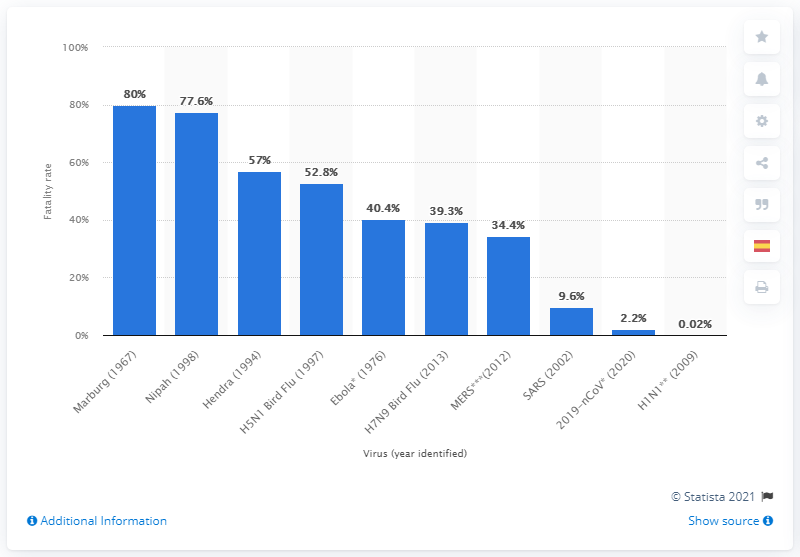Identify some key points in this picture. As of January 31, 2020, the fatality rate of the novel coronavirus in Wuhan was 2.2%. 